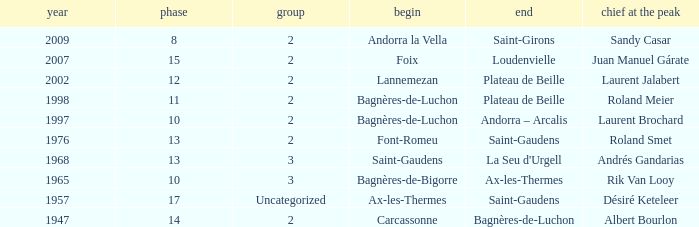Give the Finish for a Stage that is larger than 15 Saint-Gaudens. 